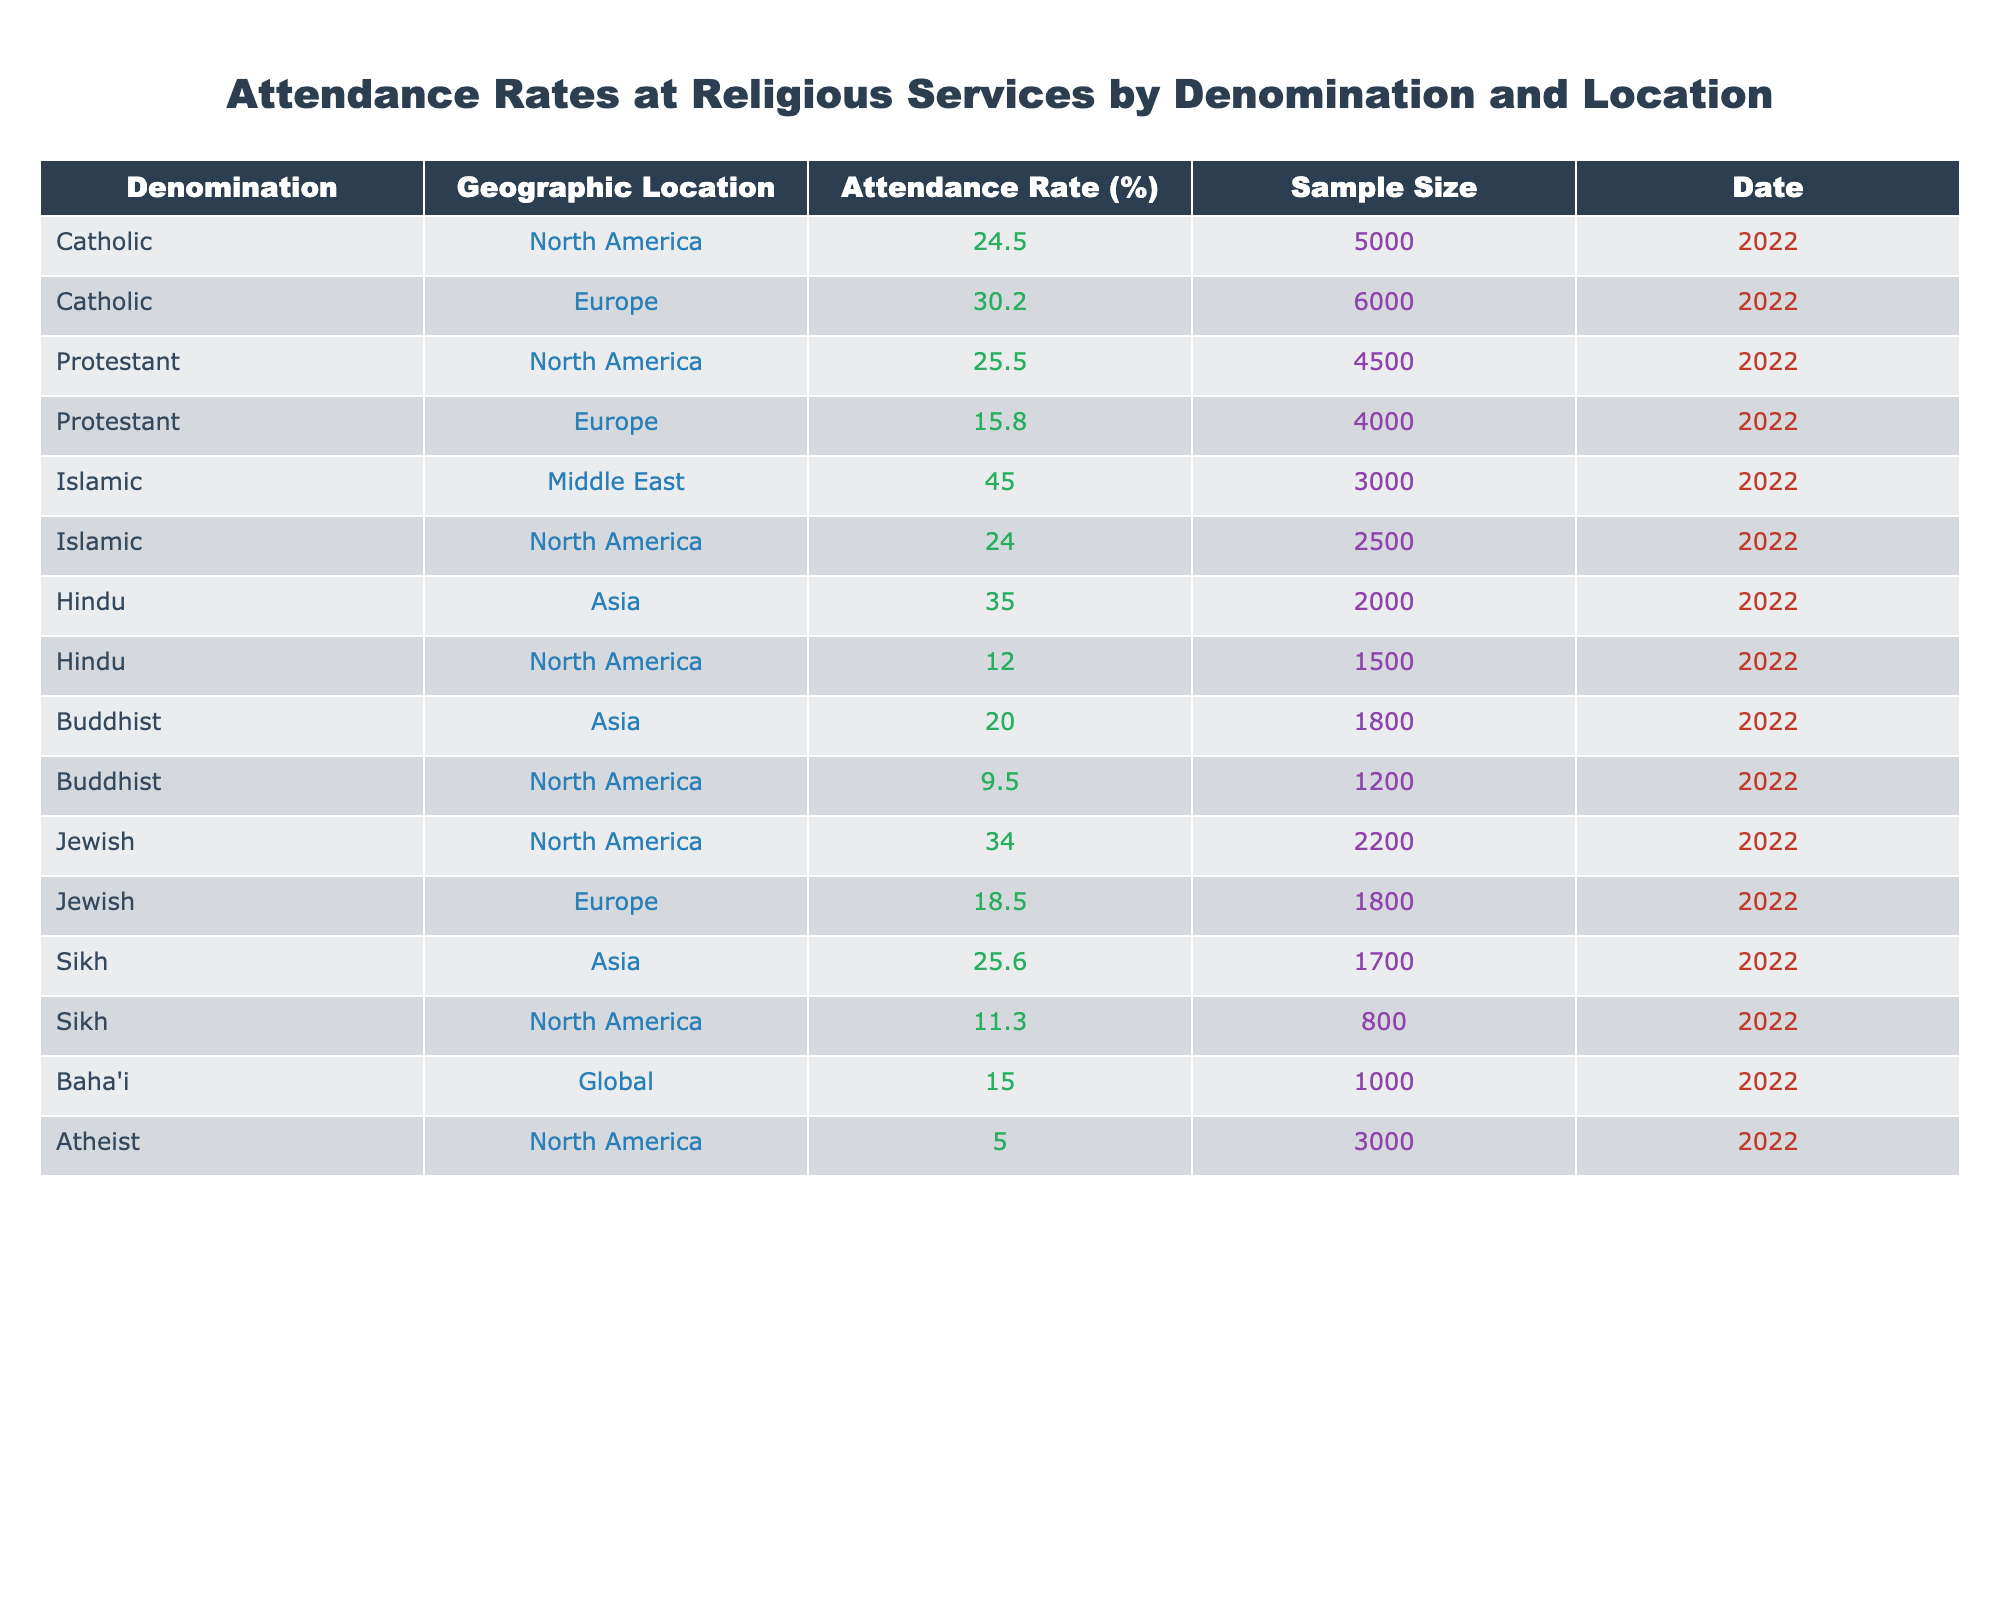What is the attendance rate for Catholics in Europe? According to the table, the attendance rate for Catholics in Europe is listed as 30.2%.
Answer: 30.2% Which geographic location has the highest attendance rate for Islamic services? The table shows that the Middle East has the highest attendance rate for Islamic services at 45.0%.
Answer: 45.0% What is the attendance rate difference between Protestant services in North America and Europe? The attendance rate for Protestants in North America is 25.5%, while in Europe it is 15.8%. The difference is calculated as 25.5% - 15.8% = 9.7%.
Answer: 9.7% Is the attendance rate for Hindus in North America higher than that for Buddhists in the same location? The table indicates that the attendance rate for Hindus in North America is 12.0%, while for Buddhists it is 9.5%. Since 12.0% is greater than 9.5%, the statement is true.
Answer: Yes What is the average attendance rate for all religions in North America? The attendance rates for North America are: Catholics 24.5%, Protestants 25.5%, Islamic 24.0%, Hindu 12.0%, Buddhist 9.5%, Jewish 34.0%, Sikh 11.3%, and Atheist 5.0%. To find the average: (24.5 + 25.5 + 24.0 + 12.0 + 9.5 + 34.0 + 11.3 + 5.0) / 8 = 17.29%.
Answer: 17.29% Are there any denominations in Asia with lower attendance rates than the one for Buddhists in North America? The attendance rate for Buddhists in North America is 9.5%. In Asia, the attendance rates are: Hindu 35.0% and Sikh 25.6%. Both are higher than 9.5%, resulting in a conclusion of no denomination having a lower rate.
Answer: No Which religious group has the lowest attendance rate across all geographic locations in the table? The table shows that Atheists in North America have the lowest attendance rate at 5.0%.
Answer: 5.0% What percentage of the sample size consists of attendees for Islamic services in North America? The attendance rate for Islamic services in North America is 24.0% from a sample size of 2500. To determine the number of attendees: 24.0% of 2500 = (24/100) * 2500 = 600.
Answer: 600 How do the attendance rates for Jewish services compare between North America and Europe? The attendance rate for Jewish services in North America is 34.0%, while in Europe it is 18.5%. The North American attendance rate is significantly higher than that of Europe.
Answer: Higher in North America What is the collective attendance rate for Baha'i services globally according to the table? The table indicates a global attendance rate for Baha'i services at 15.0%.
Answer: 15.0% 